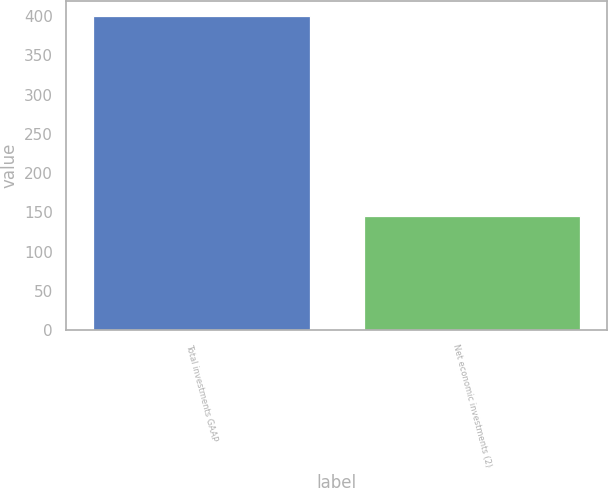Convert chart. <chart><loc_0><loc_0><loc_500><loc_500><bar_chart><fcel>Total investments GAAP<fcel>Net economic investments (2)<nl><fcel>400<fcel>145<nl></chart> 